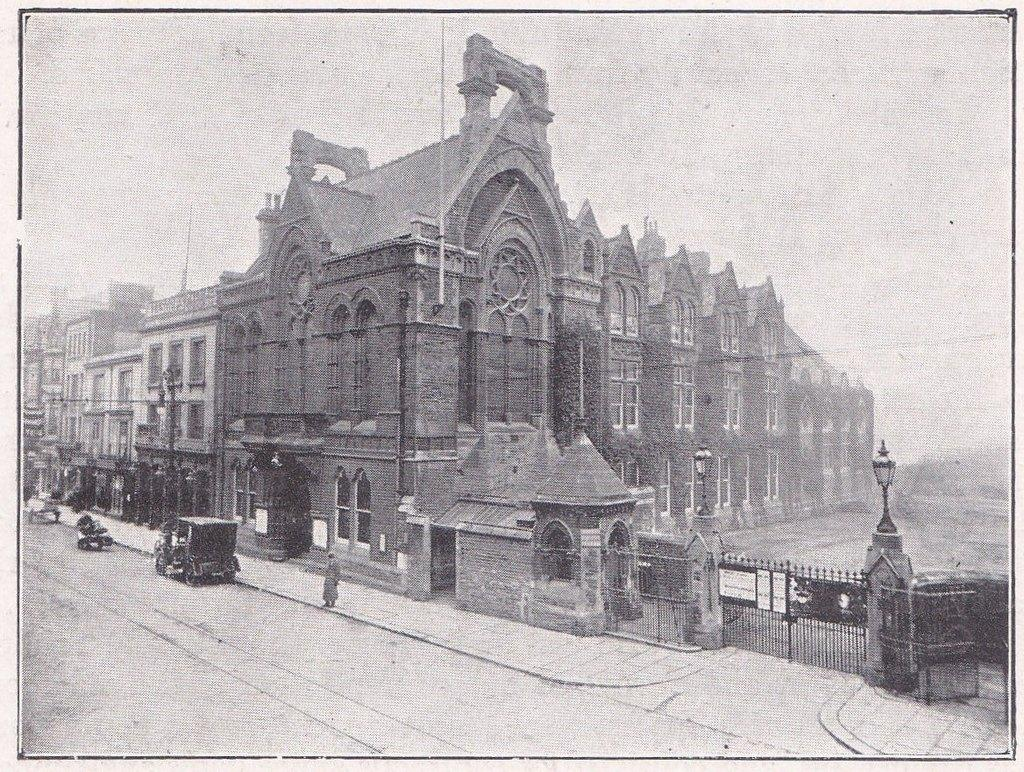What type of structures can be seen in the image? There are buildings in the image. What type of barrier is present in the image? There is a fence in the image. Are there any entrances or exits visible in the image? Yes, there are gates in the image. What type of transportation can be seen on the road in the image? Vehicles are present on the road in the image. What is the color scheme of the image? The image is black and white in color. What is visible in the background of the image? The sky is visible in the background of the image. Can you see any clams on the coast in the image? There is no coast or clams present in the image; it features buildings, a fence, gates, vehicles, and a black and white color scheme. What type of pail is being used to collect water from the well in the image? There is no well or pail present in the image. 